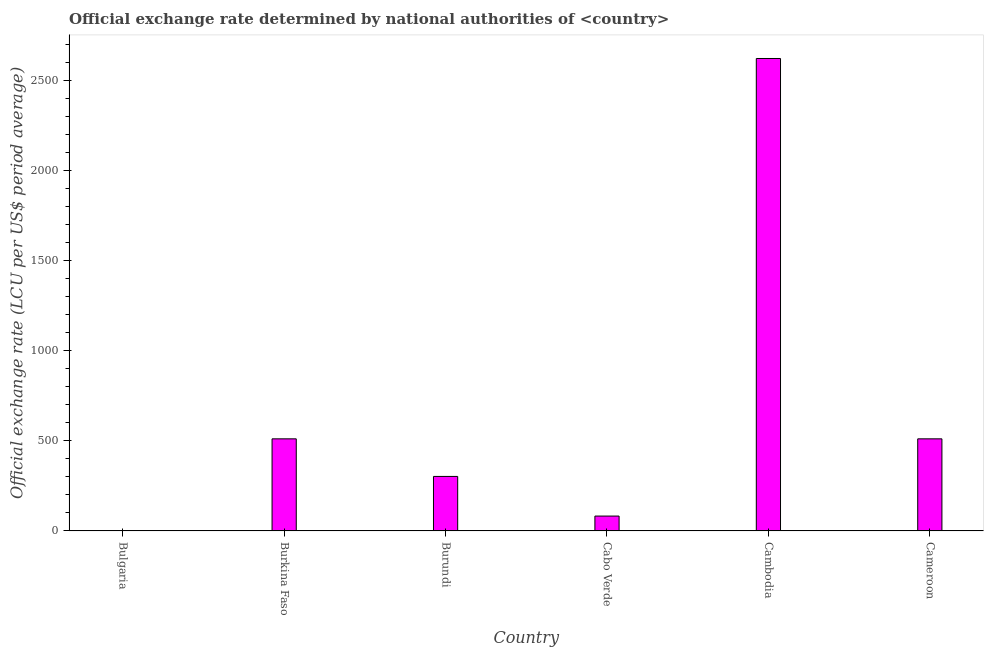Does the graph contain grids?
Provide a short and direct response. No. What is the title of the graph?
Your response must be concise. Official exchange rate determined by national authorities of <country>. What is the label or title of the Y-axis?
Your answer should be very brief. Official exchange rate (LCU per US$ period average). What is the official exchange rate in Bulgaria?
Your answer should be compact. 0.18. Across all countries, what is the maximum official exchange rate?
Make the answer very short. 2624.08. Across all countries, what is the minimum official exchange rate?
Ensure brevity in your answer.  0.18. In which country was the official exchange rate maximum?
Ensure brevity in your answer.  Cambodia. In which country was the official exchange rate minimum?
Give a very brief answer. Bulgaria. What is the sum of the official exchange rate?
Your response must be concise. 4032.7. What is the difference between the official exchange rate in Bulgaria and Cambodia?
Offer a terse response. -2623.91. What is the average official exchange rate per country?
Your answer should be compact. 672.12. What is the median official exchange rate?
Provide a succinct answer. 407.15. What is the ratio of the official exchange rate in Burkina Faso to that in Cambodia?
Your response must be concise. 0.2. Is the difference between the official exchange rate in Cabo Verde and Cameroon greater than the difference between any two countries?
Offer a very short reply. No. What is the difference between the highest and the second highest official exchange rate?
Offer a terse response. 2112.53. Is the sum of the official exchange rate in Bulgaria and Cabo Verde greater than the maximum official exchange rate across all countries?
Offer a very short reply. No. What is the difference between the highest and the lowest official exchange rate?
Keep it short and to the point. 2623.91. How many bars are there?
Your answer should be very brief. 6. Are all the bars in the graph horizontal?
Your answer should be compact. No. What is the Official exchange rate (LCU per US$ period average) of Bulgaria?
Your response must be concise. 0.18. What is the Official exchange rate (LCU per US$ period average) in Burkina Faso?
Your answer should be very brief. 511.55. What is the Official exchange rate (LCU per US$ period average) of Burundi?
Offer a terse response. 302.75. What is the Official exchange rate (LCU per US$ period average) in Cabo Verde?
Make the answer very short. 82.59. What is the Official exchange rate (LCU per US$ period average) in Cambodia?
Provide a succinct answer. 2624.08. What is the Official exchange rate (LCU per US$ period average) of Cameroon?
Keep it short and to the point. 511.55. What is the difference between the Official exchange rate (LCU per US$ period average) in Bulgaria and Burkina Faso?
Ensure brevity in your answer.  -511.37. What is the difference between the Official exchange rate (LCU per US$ period average) in Bulgaria and Burundi?
Keep it short and to the point. -302.57. What is the difference between the Official exchange rate (LCU per US$ period average) in Bulgaria and Cabo Verde?
Offer a terse response. -82.41. What is the difference between the Official exchange rate (LCU per US$ period average) in Bulgaria and Cambodia?
Offer a very short reply. -2623.91. What is the difference between the Official exchange rate (LCU per US$ period average) in Bulgaria and Cameroon?
Offer a terse response. -511.37. What is the difference between the Official exchange rate (LCU per US$ period average) in Burkina Faso and Burundi?
Provide a succinct answer. 208.81. What is the difference between the Official exchange rate (LCU per US$ period average) in Burkina Faso and Cabo Verde?
Give a very brief answer. 428.96. What is the difference between the Official exchange rate (LCU per US$ period average) in Burkina Faso and Cambodia?
Provide a succinct answer. -2112.53. What is the difference between the Official exchange rate (LCU per US$ period average) in Burundi and Cabo Verde?
Provide a succinct answer. 220.16. What is the difference between the Official exchange rate (LCU per US$ period average) in Burundi and Cambodia?
Offer a terse response. -2321.34. What is the difference between the Official exchange rate (LCU per US$ period average) in Burundi and Cameroon?
Your answer should be compact. -208.81. What is the difference between the Official exchange rate (LCU per US$ period average) in Cabo Verde and Cambodia?
Offer a terse response. -2541.49. What is the difference between the Official exchange rate (LCU per US$ period average) in Cabo Verde and Cameroon?
Your answer should be very brief. -428.96. What is the difference between the Official exchange rate (LCU per US$ period average) in Cambodia and Cameroon?
Keep it short and to the point. 2112.53. What is the ratio of the Official exchange rate (LCU per US$ period average) in Bulgaria to that in Burundi?
Your response must be concise. 0. What is the ratio of the Official exchange rate (LCU per US$ period average) in Bulgaria to that in Cabo Verde?
Your response must be concise. 0. What is the ratio of the Official exchange rate (LCU per US$ period average) in Bulgaria to that in Cameroon?
Offer a very short reply. 0. What is the ratio of the Official exchange rate (LCU per US$ period average) in Burkina Faso to that in Burundi?
Provide a short and direct response. 1.69. What is the ratio of the Official exchange rate (LCU per US$ period average) in Burkina Faso to that in Cabo Verde?
Offer a very short reply. 6.19. What is the ratio of the Official exchange rate (LCU per US$ period average) in Burkina Faso to that in Cambodia?
Ensure brevity in your answer.  0.2. What is the ratio of the Official exchange rate (LCU per US$ period average) in Burundi to that in Cabo Verde?
Your response must be concise. 3.67. What is the ratio of the Official exchange rate (LCU per US$ period average) in Burundi to that in Cambodia?
Your answer should be compact. 0.12. What is the ratio of the Official exchange rate (LCU per US$ period average) in Burundi to that in Cameroon?
Provide a succinct answer. 0.59. What is the ratio of the Official exchange rate (LCU per US$ period average) in Cabo Verde to that in Cambodia?
Your answer should be compact. 0.03. What is the ratio of the Official exchange rate (LCU per US$ period average) in Cabo Verde to that in Cameroon?
Provide a short and direct response. 0.16. What is the ratio of the Official exchange rate (LCU per US$ period average) in Cambodia to that in Cameroon?
Offer a very short reply. 5.13. 